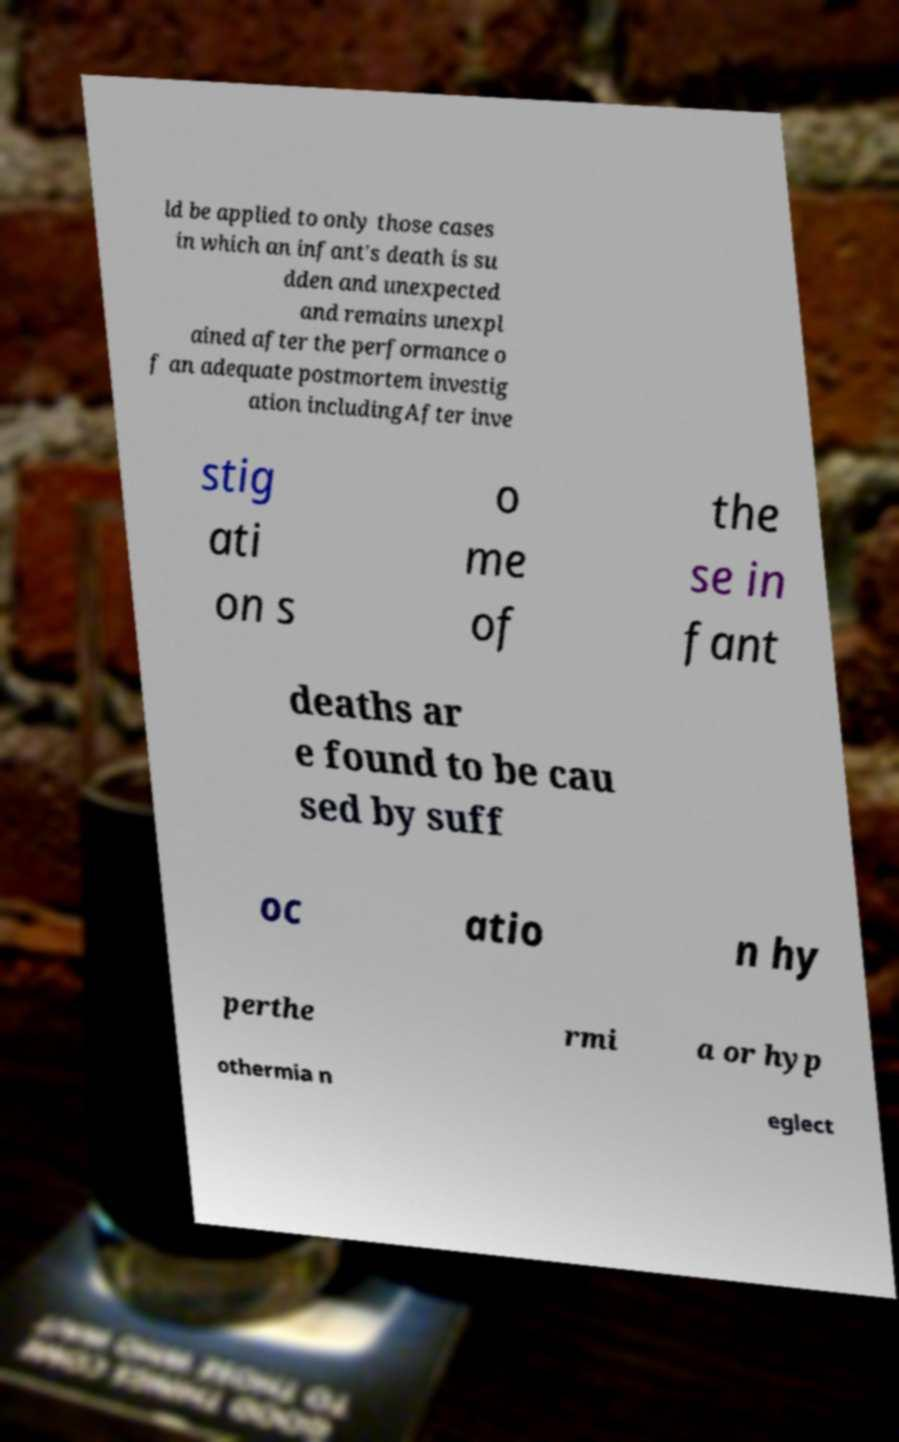Could you assist in decoding the text presented in this image and type it out clearly? ld be applied to only those cases in which an infant's death is su dden and unexpected and remains unexpl ained after the performance o f an adequate postmortem investig ation includingAfter inve stig ati on s o me of the se in fant deaths ar e found to be cau sed by suff oc atio n hy perthe rmi a or hyp othermia n eglect 